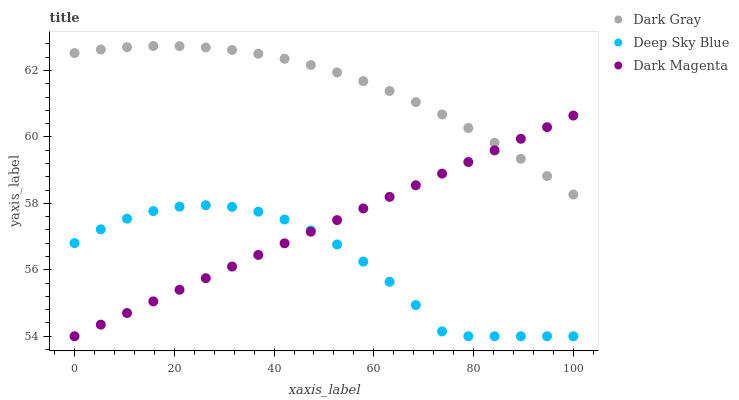Does Deep Sky Blue have the minimum area under the curve?
Answer yes or no. Yes. Does Dark Gray have the maximum area under the curve?
Answer yes or no. Yes. Does Dark Magenta have the minimum area under the curve?
Answer yes or no. No. Does Dark Magenta have the maximum area under the curve?
Answer yes or no. No. Is Dark Magenta the smoothest?
Answer yes or no. Yes. Is Deep Sky Blue the roughest?
Answer yes or no. Yes. Is Deep Sky Blue the smoothest?
Answer yes or no. No. Is Dark Magenta the roughest?
Answer yes or no. No. Does Dark Magenta have the lowest value?
Answer yes or no. Yes. Does Dark Gray have the highest value?
Answer yes or no. Yes. Does Dark Magenta have the highest value?
Answer yes or no. No. Is Deep Sky Blue less than Dark Gray?
Answer yes or no. Yes. Is Dark Gray greater than Deep Sky Blue?
Answer yes or no. Yes. Does Dark Magenta intersect Deep Sky Blue?
Answer yes or no. Yes. Is Dark Magenta less than Deep Sky Blue?
Answer yes or no. No. Is Dark Magenta greater than Deep Sky Blue?
Answer yes or no. No. Does Deep Sky Blue intersect Dark Gray?
Answer yes or no. No. 